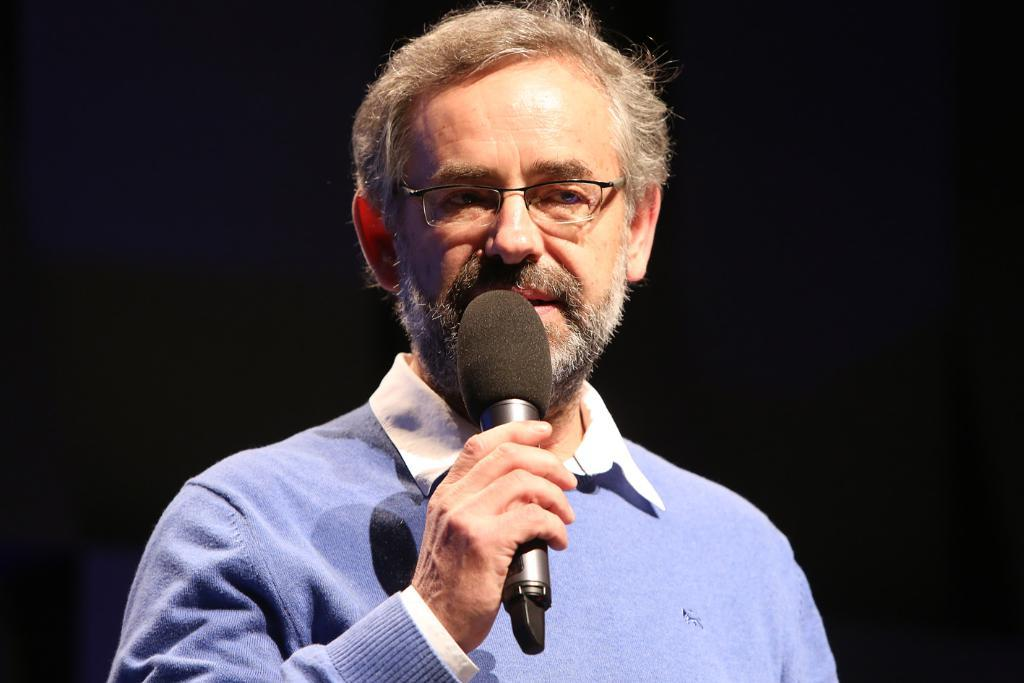Who is the main subject in the image? There is a man in the image. Where is the man positioned in the image? The man is standing in the center of the image. What is the man holding in his hand? The man is holding a mic in his hand. How many cobwebs can be seen in the image? There are no cobwebs present in the image. What is the hour depicted in the image? The provided facts do not mention any specific time or hour in the image. 